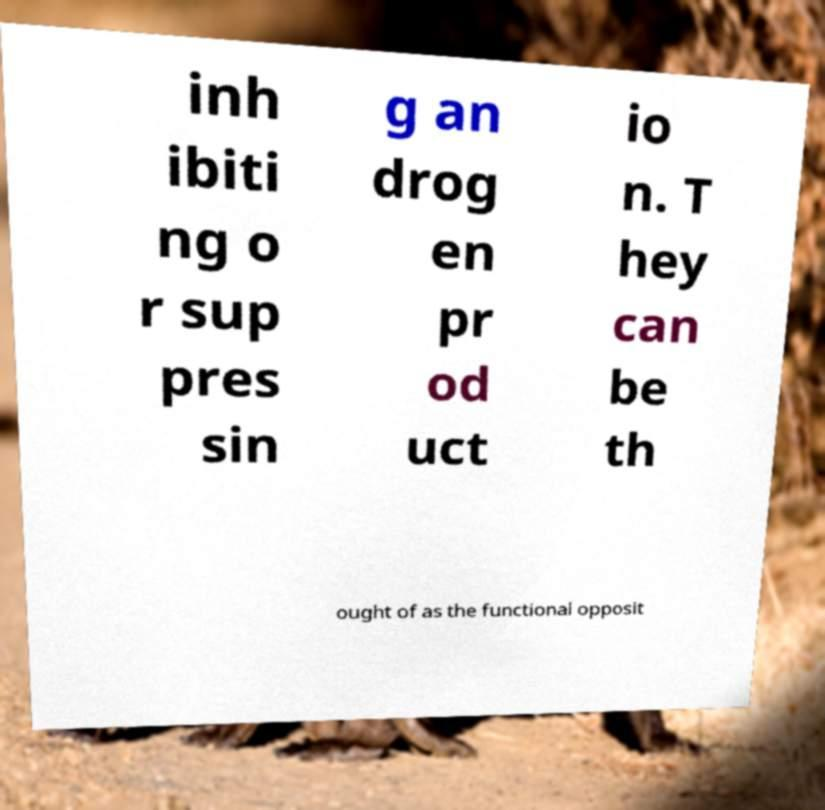Could you assist in decoding the text presented in this image and type it out clearly? inh ibiti ng o r sup pres sin g an drog en pr od uct io n. T hey can be th ought of as the functional opposit 